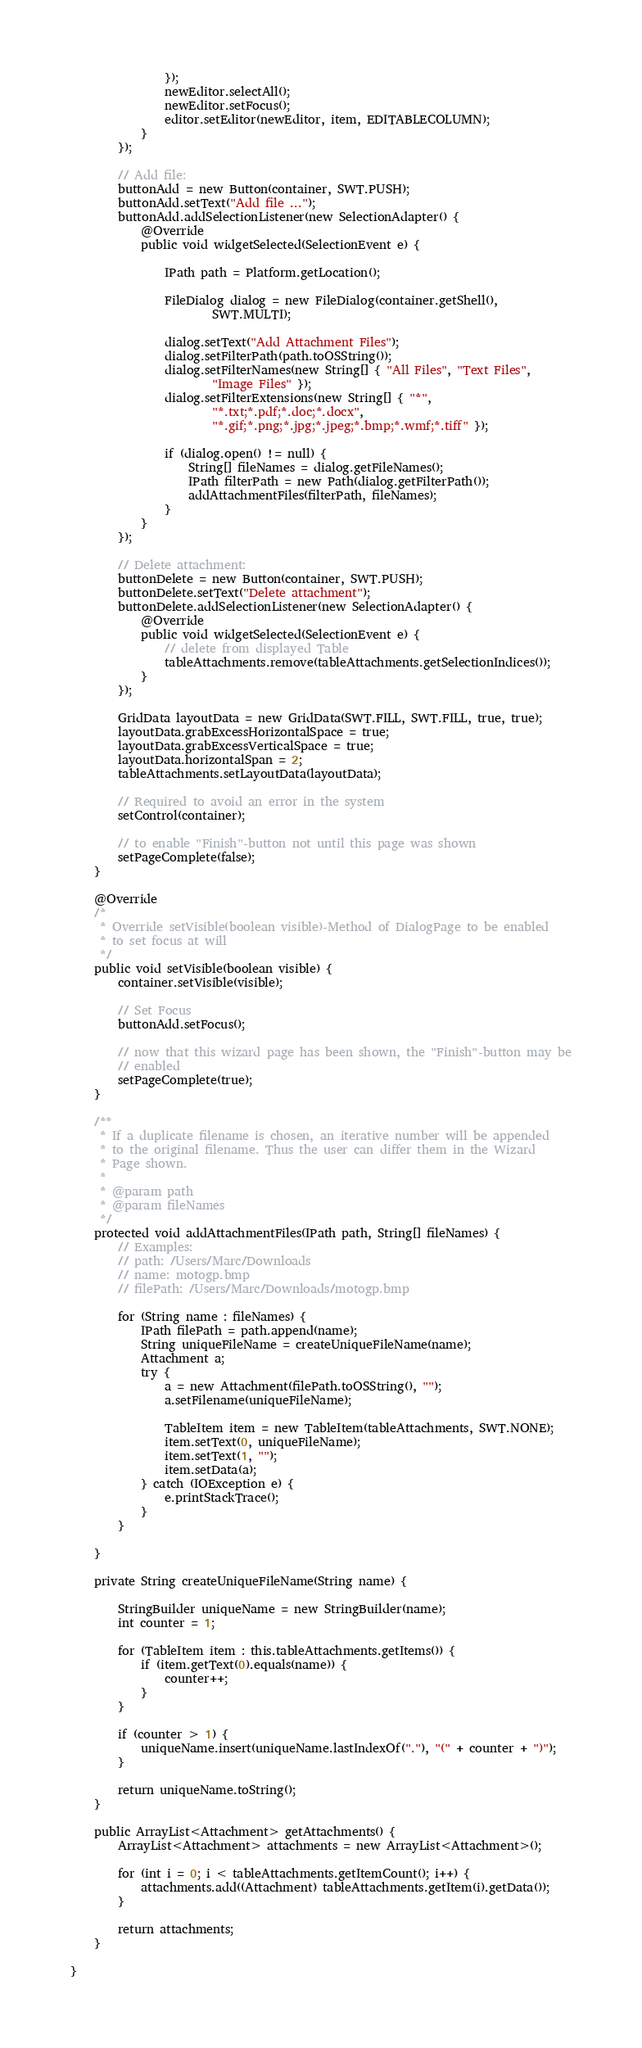Convert code to text. <code><loc_0><loc_0><loc_500><loc_500><_Java_>				});
				newEditor.selectAll();
				newEditor.setFocus();
				editor.setEditor(newEditor, item, EDITABLECOLUMN);
			}
		});

		// Add file:
		buttonAdd = new Button(container, SWT.PUSH);
		buttonAdd.setText("Add file ...");
		buttonAdd.addSelectionListener(new SelectionAdapter() {
			@Override
			public void widgetSelected(SelectionEvent e) {

				IPath path = Platform.getLocation();

				FileDialog dialog = new FileDialog(container.getShell(),
						SWT.MULTI);

				dialog.setText("Add Attachment Files");
				dialog.setFilterPath(path.toOSString());
				dialog.setFilterNames(new String[] { "All Files", "Text Files",
						"Image Files" });
				dialog.setFilterExtensions(new String[] { "*",
						"*.txt;*.pdf;*.doc;*.docx",
						"*.gif;*.png;*.jpg;*.jpeg;*.bmp;*.wmf;*.tiff" });

				if (dialog.open() != null) {
					String[] fileNames = dialog.getFileNames();
					IPath filterPath = new Path(dialog.getFilterPath());
					addAttachmentFiles(filterPath, fileNames);
				}
			}
		});

		// Delete attachment:
		buttonDelete = new Button(container, SWT.PUSH);
		buttonDelete.setText("Delete attachment");
		buttonDelete.addSelectionListener(new SelectionAdapter() {
			@Override
			public void widgetSelected(SelectionEvent e) {
				// delete from displayed Table
				tableAttachments.remove(tableAttachments.getSelectionIndices());
			}
		});

		GridData layoutData = new GridData(SWT.FILL, SWT.FILL, true, true);
		layoutData.grabExcessHorizontalSpace = true;
		layoutData.grabExcessVerticalSpace = true;
		layoutData.horizontalSpan = 2;
		tableAttachments.setLayoutData(layoutData);

		// Required to avoid an error in the system
		setControl(container);

		// to enable "Finish"-button not until this page was shown
		setPageComplete(false);
	}

	@Override
	/*
	 * Override setVisible(boolean visible)-Method of DialogPage to be enabled
	 * to set focus at will
	 */
	public void setVisible(boolean visible) {
		container.setVisible(visible);

		// Set Focus
		buttonAdd.setFocus();

		// now that this wizard page has been shown, the "Finish"-button may be
		// enabled
		setPageComplete(true);
	}

	/**
	 * If a duplicate filename is chosen, an iterative number will be appended
	 * to the original filename. Thus the user can differ them in the Wizard
	 * Page shown.
	 * 
	 * @param path
	 * @param fileNames
	 */
	protected void addAttachmentFiles(IPath path, String[] fileNames) {
		// Examples:
		// path: /Users/Marc/Downloads
		// name: motogp.bmp
		// filePath: /Users/Marc/Downloads/motogp.bmp

		for (String name : fileNames) {
			IPath filePath = path.append(name);
			String uniqueFileName = createUniqueFileName(name);
			Attachment a;
			try {
				a = new Attachment(filePath.toOSString(), "");
				a.setFilename(uniqueFileName);

				TableItem item = new TableItem(tableAttachments, SWT.NONE);
				item.setText(0, uniqueFileName);
				item.setText(1, "");
				item.setData(a);
			} catch (IOException e) {
				e.printStackTrace();
			}
		}

	}

	private String createUniqueFileName(String name) {

		StringBuilder uniqueName = new StringBuilder(name);
		int counter = 1;

		for (TableItem item : this.tableAttachments.getItems()) {
			if (item.getText(0).equals(name)) {
				counter++;
			}
		}

		if (counter > 1) {
			uniqueName.insert(uniqueName.lastIndexOf("."), "(" + counter + ")");
		}

		return uniqueName.toString();
	}

	public ArrayList<Attachment> getAttachments() {
		ArrayList<Attachment> attachments = new ArrayList<Attachment>();

		for (int i = 0; i < tableAttachments.getItemCount(); i++) {
			attachments.add((Attachment) tableAttachments.getItem(i).getData());
		}

		return attachments;
	}

}
</code> 